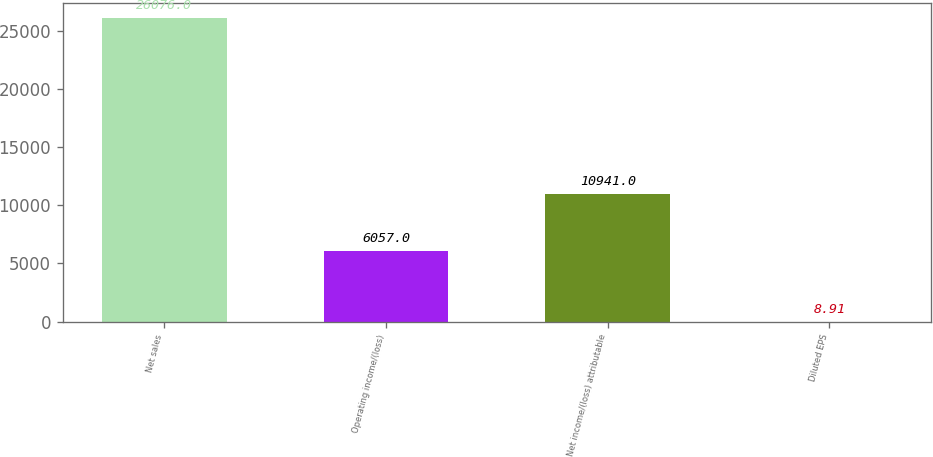<chart> <loc_0><loc_0><loc_500><loc_500><bar_chart><fcel>Net sales<fcel>Operating income/(loss)<fcel>Net income/(loss) attributable<fcel>Diluted EPS<nl><fcel>26076<fcel>6057<fcel>10941<fcel>8.91<nl></chart> 